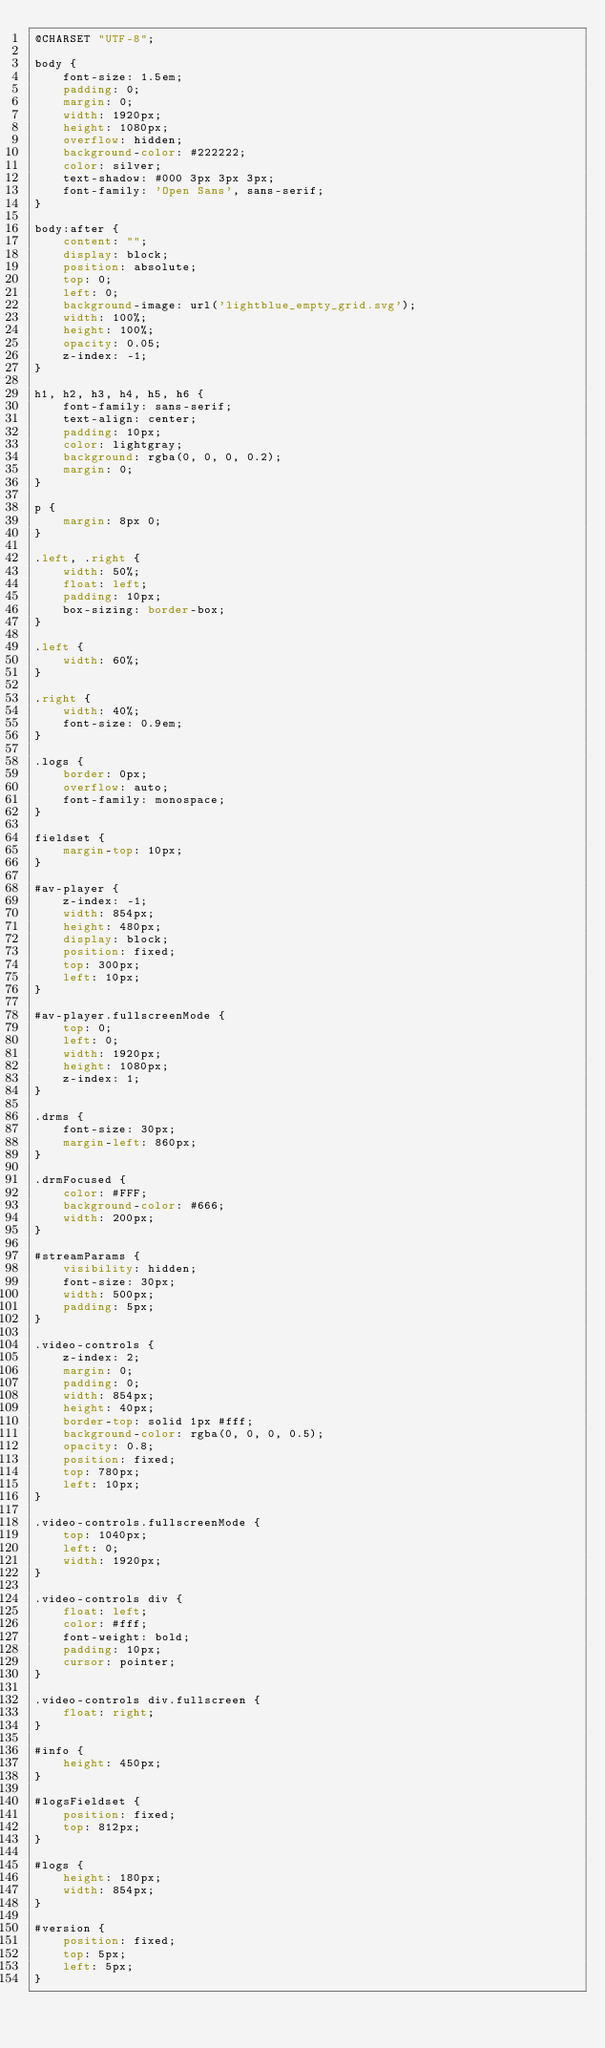<code> <loc_0><loc_0><loc_500><loc_500><_CSS_>@CHARSET "UTF-8";

body {
    font-size: 1.5em;
    padding: 0;
    margin: 0;
    width: 1920px;
    height: 1080px;
    overflow: hidden;
    background-color: #222222;
    color: silver;
    text-shadow: #000 3px 3px 3px;
    font-family: 'Open Sans', sans-serif;
}

body:after {
    content: "";
    display: block;
    position: absolute;
    top: 0;
    left: 0;
    background-image: url('lightblue_empty_grid.svg');
    width: 100%;
    height: 100%;
    opacity: 0.05;
    z-index: -1;
}

h1, h2, h3, h4, h5, h6 {
    font-family: sans-serif;
    text-align: center;
    padding: 10px;
    color: lightgray;
    background: rgba(0, 0, 0, 0.2);
    margin: 0;
}

p {
    margin: 8px 0;
}

.left, .right {
    width: 50%;
    float: left;
    padding: 10px;
    box-sizing: border-box;
}

.left {
    width: 60%;
}

.right {
    width: 40%;
    font-size: 0.9em;
}

.logs {
    border: 0px;
    overflow: auto;
    font-family: monospace;
}

fieldset {
    margin-top: 10px;
}

#av-player {
    z-index: -1;
    width: 854px;
    height: 480px;
    display: block;
    position: fixed;
    top: 300px;
    left: 10px;
}

#av-player.fullscreenMode {
    top: 0;
    left: 0;
    width: 1920px;
    height: 1080px;
    z-index: 1;
}

.drms {
    font-size: 30px;
    margin-left: 860px;
}

.drmFocused {
    color: #FFF;
    background-color: #666;
    width: 200px;
}

#streamParams {
    visibility: hidden;
    font-size: 30px;
    width: 500px;
    padding: 5px;
}

.video-controls {
    z-index: 2;
    margin: 0;
    padding: 0;
    width: 854px;
    height: 40px;
    border-top: solid 1px #fff;
    background-color: rgba(0, 0, 0, 0.5);
    opacity: 0.8;
    position: fixed;
    top: 780px;
    left: 10px;
}

.video-controls.fullscreenMode {
    top: 1040px;
    left: 0;
    width: 1920px;
}

.video-controls div {
    float: left;
    color: #fff;
    font-weight: bold;
    padding: 10px;
    cursor: pointer;
}

.video-controls div.fullscreen {
    float: right;
}

#info {
    height: 450px;
}

#logsFieldset {
    position: fixed;
    top: 812px;
}

#logs {
    height: 180px;
    width: 854px;
}

#version {
    position: fixed;
    top: 5px;
    left: 5px;
}
</code> 